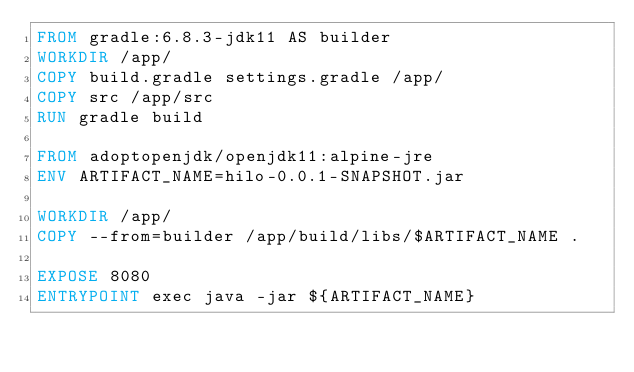Convert code to text. <code><loc_0><loc_0><loc_500><loc_500><_Dockerfile_>FROM gradle:6.8.3-jdk11 AS builder
WORKDIR /app/
COPY build.gradle settings.gradle /app/
COPY src /app/src
RUN gradle build

FROM adoptopenjdk/openjdk11:alpine-jre
ENV ARTIFACT_NAME=hilo-0.0.1-SNAPSHOT.jar

WORKDIR /app/
COPY --from=builder /app/build/libs/$ARTIFACT_NAME .

EXPOSE 8080
ENTRYPOINT exec java -jar ${ARTIFACT_NAME}
</code> 